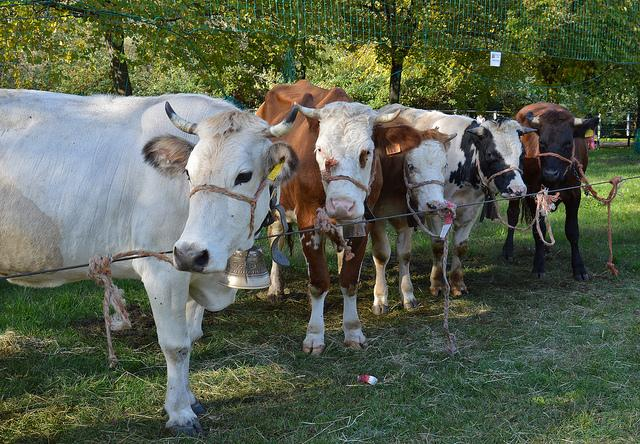What is the most common breed of milk cow?

Choices:
A) brown swiss
B) holstein
C) ayrshire
D) jersey holstein 